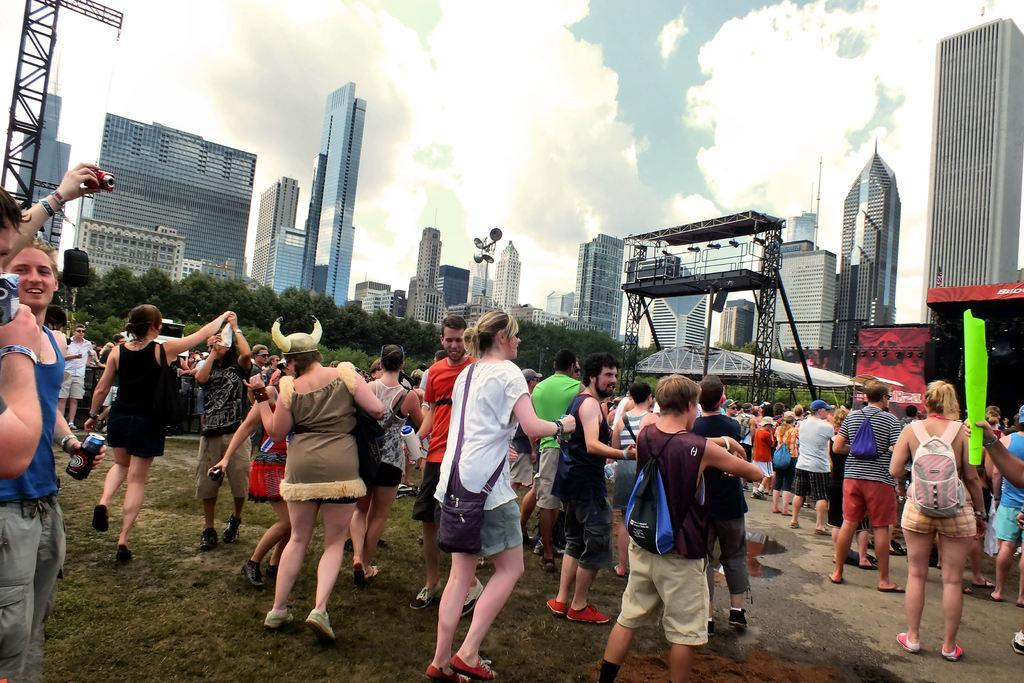What can be seen in the image? There are people standing in the image. What is visible in the background of the image? In the background of the image, there are speakers, lights, buildings, trees, and the sky. What might be used for amplifying sound in the image? The speakers in the background of the image might be used for amplifying sound. What type of vegetation is visible in the background of the image? Trees are visible in the background of the image. Can you tell me how many kittens are climbing the cable in the image? There are no kittens or cables present in the image. What is the reason for the people falling in the image? There is no indication in the image that anyone is falling. 